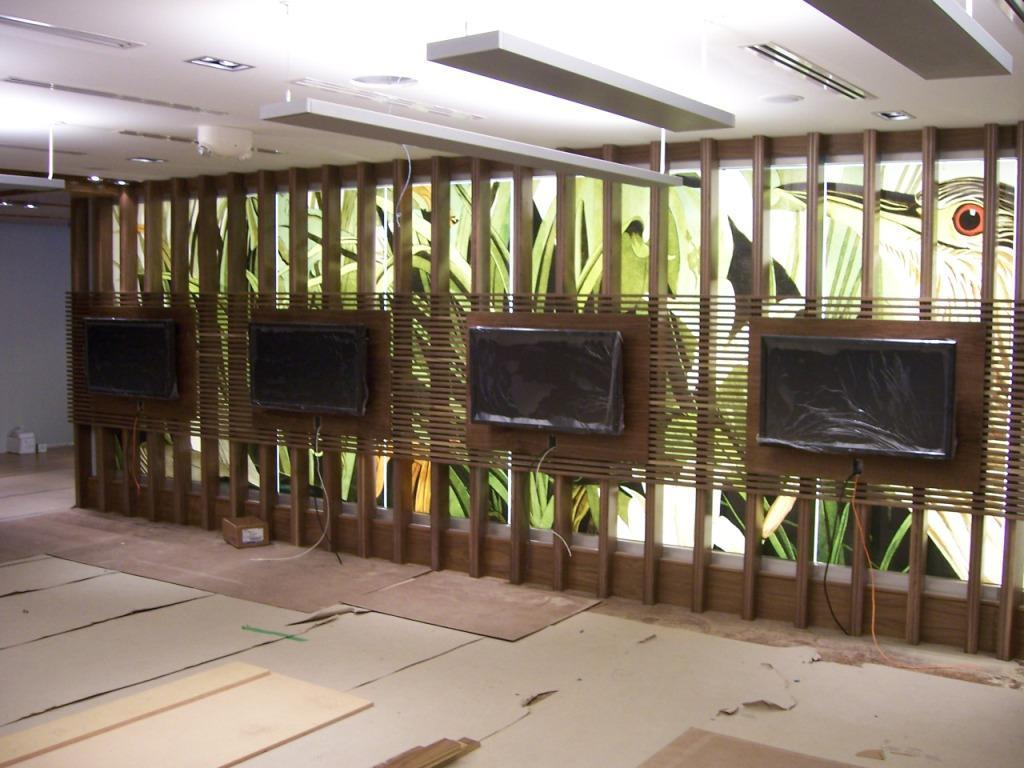What can be seen running through the image? There is a path in the image. What type of wall is present in the image? There is a wall with wooden planks in the image. What is illuminating the area in the image? There are lights visible on the ceiling in the image. Where is the paper located in the image? There is no paper present in the image. What type of mitten is hanging on the wall in the image? There is no mitten present in the image. 